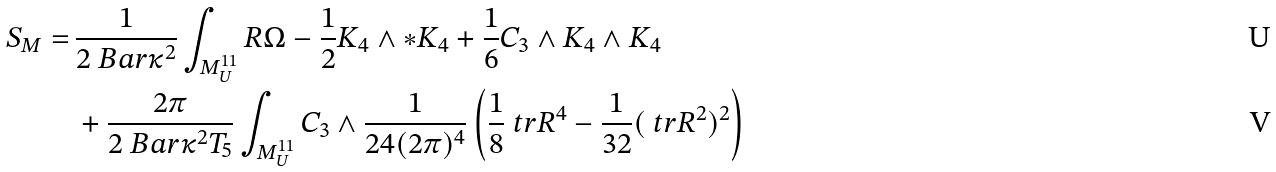Convert formula to latex. <formula><loc_0><loc_0><loc_500><loc_500>S _ { M } = \, & \frac { 1 } { 2 \ B a r { \kappa } ^ { 2 } } \int _ { M ^ { 1 1 } _ { U } } R \Omega - \frac { 1 } { 2 } K _ { 4 } \wedge * K _ { 4 } + \frac { 1 } { 6 } C _ { 3 } \wedge K _ { 4 } \wedge K _ { 4 } \\ & + \frac { 2 \pi } { 2 \ B a r { \kappa } ^ { 2 } T _ { 5 } } \int _ { M ^ { 1 1 } _ { U } } C _ { 3 } \wedge \frac { 1 } { 2 4 ( 2 \pi ) ^ { 4 } } \left ( \frac { 1 } { 8 } \ t r R ^ { 4 } - \frac { 1 } { 3 2 } ( \ t r R ^ { 2 } ) ^ { 2 } \right )</formula> 